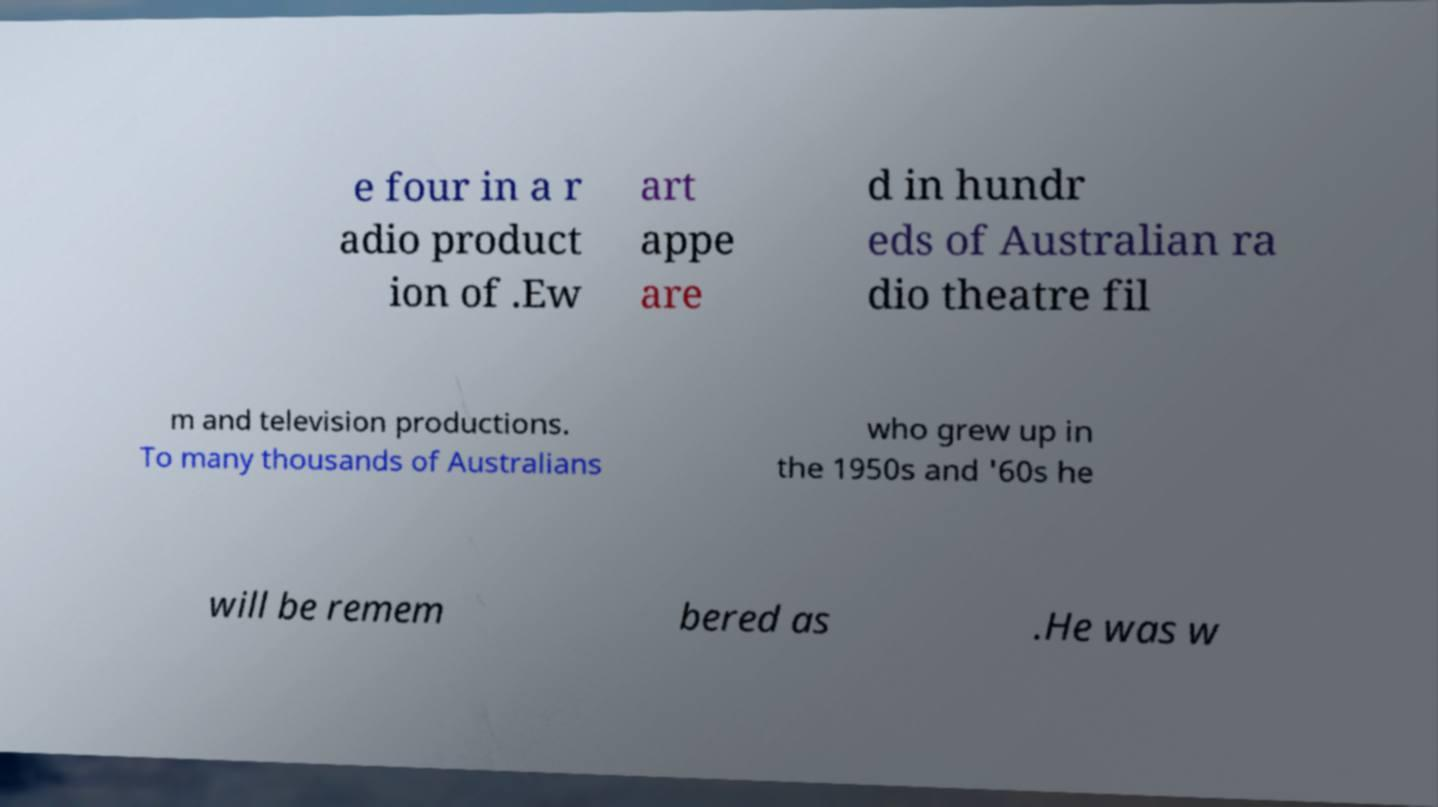There's text embedded in this image that I need extracted. Can you transcribe it verbatim? e four in a r adio product ion of .Ew art appe are d in hundr eds of Australian ra dio theatre fil m and television productions. To many thousands of Australians who grew up in the 1950s and '60s he will be remem bered as .He was w 